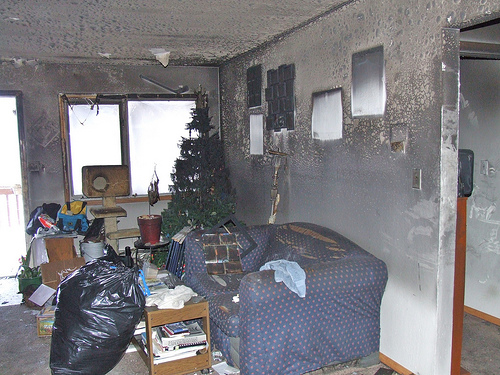<image>
Can you confirm if the tree is on the window? No. The tree is not positioned on the window. They may be near each other, but the tree is not supported by or resting on top of the window. Where is the window in relation to the tree? Is it behind the tree? Yes. From this viewpoint, the window is positioned behind the tree, with the tree partially or fully occluding the window. 